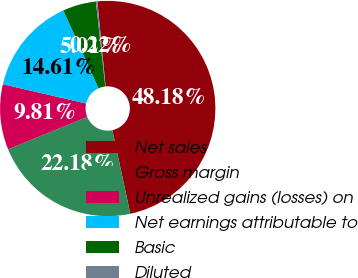Convert chart to OTSL. <chart><loc_0><loc_0><loc_500><loc_500><pie_chart><fcel>Net sales<fcel>Gross margin<fcel>Unrealized gains (losses) on<fcel>Net earnings attributable to<fcel>Basic<fcel>Diluted<nl><fcel>48.18%<fcel>22.18%<fcel>9.81%<fcel>14.61%<fcel>5.01%<fcel>0.22%<nl></chart> 